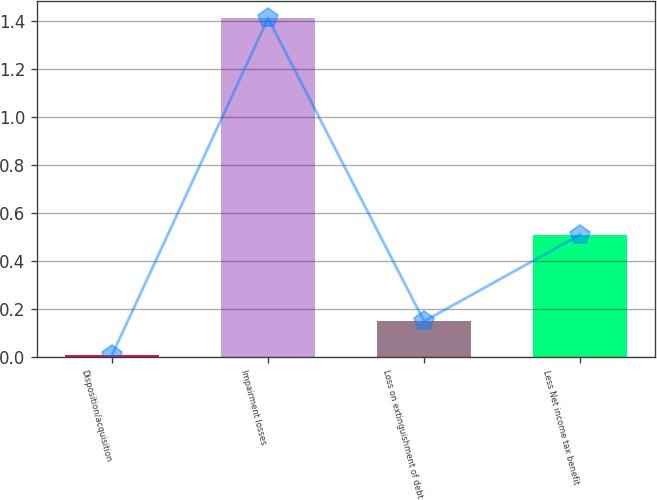Convert chart to OTSL. <chart><loc_0><loc_0><loc_500><loc_500><bar_chart><fcel>Disposition/acquisition<fcel>Impairment losses<fcel>Loss on extinguishment of debt<fcel>Less Net income tax benefit<nl><fcel>0.01<fcel>1.41<fcel>0.15<fcel>0.51<nl></chart> 